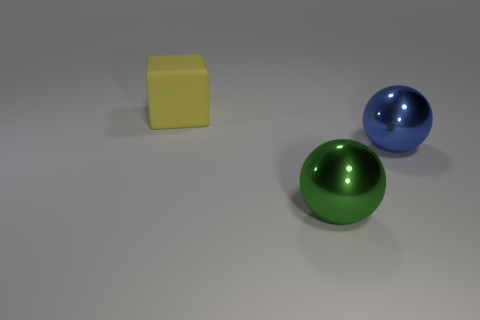Add 2 purple metal cylinders. How many objects exist? 5 Subtract all cubes. How many objects are left? 2 Subtract 0 red blocks. How many objects are left? 3 Subtract all things. Subtract all tiny brown balls. How many objects are left? 0 Add 3 big green things. How many big green things are left? 4 Add 3 big green shiny things. How many big green shiny things exist? 4 